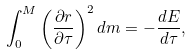<formula> <loc_0><loc_0><loc_500><loc_500>\int _ { 0 } ^ { M } \left ( \frac { \partial r } { \partial \tau } \right ) ^ { 2 } d m = - \frac { d E } { d \tau } ,</formula> 